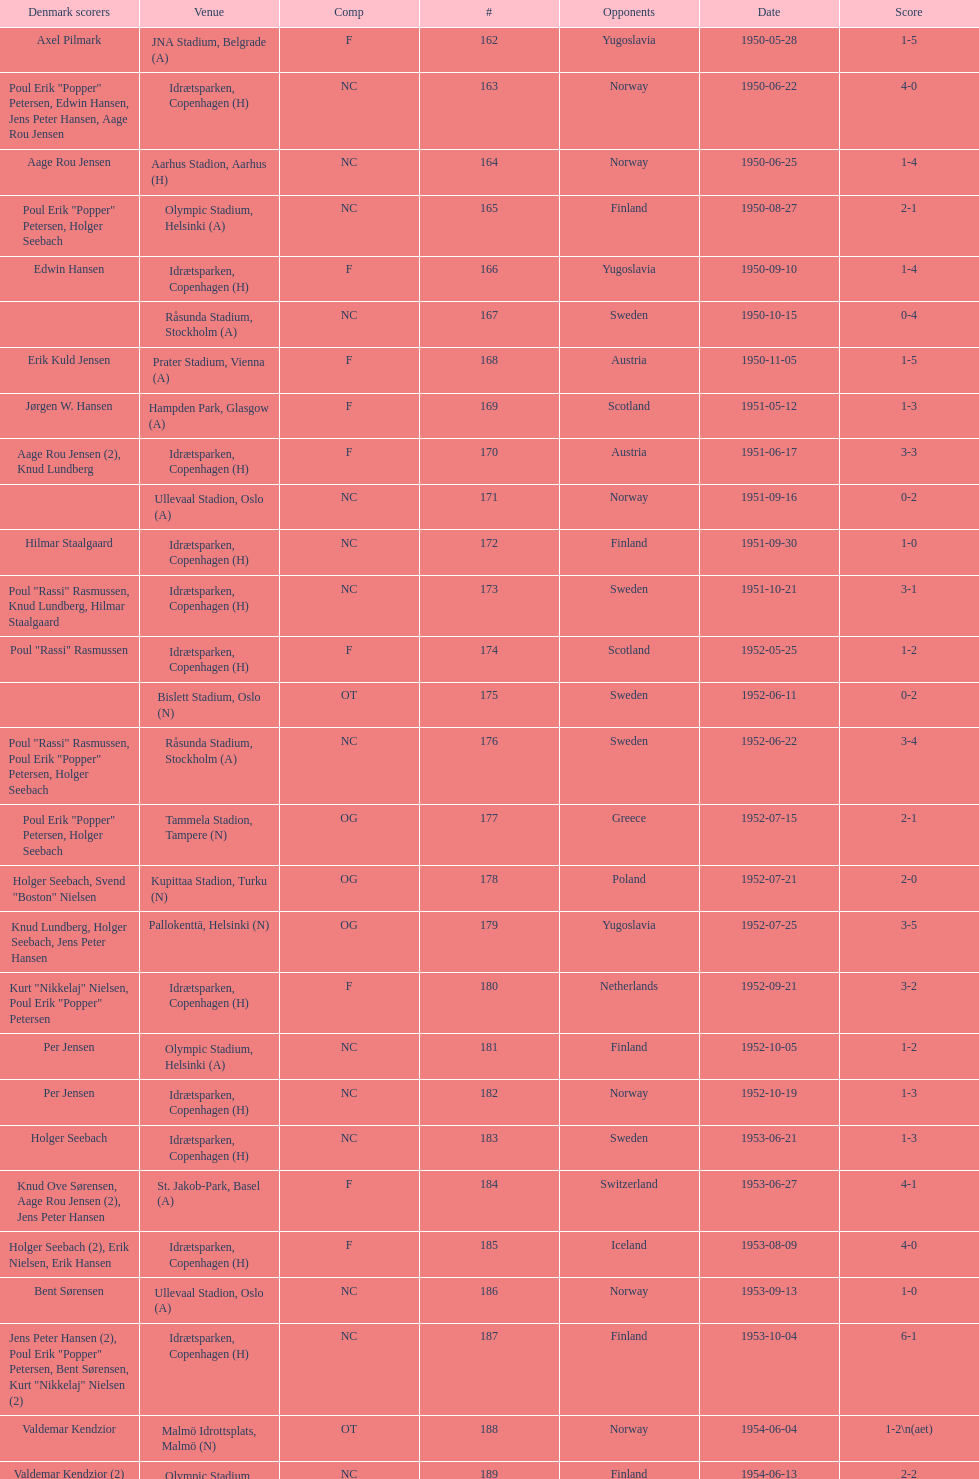What are the number of times nc appears under the comp column? 32. 